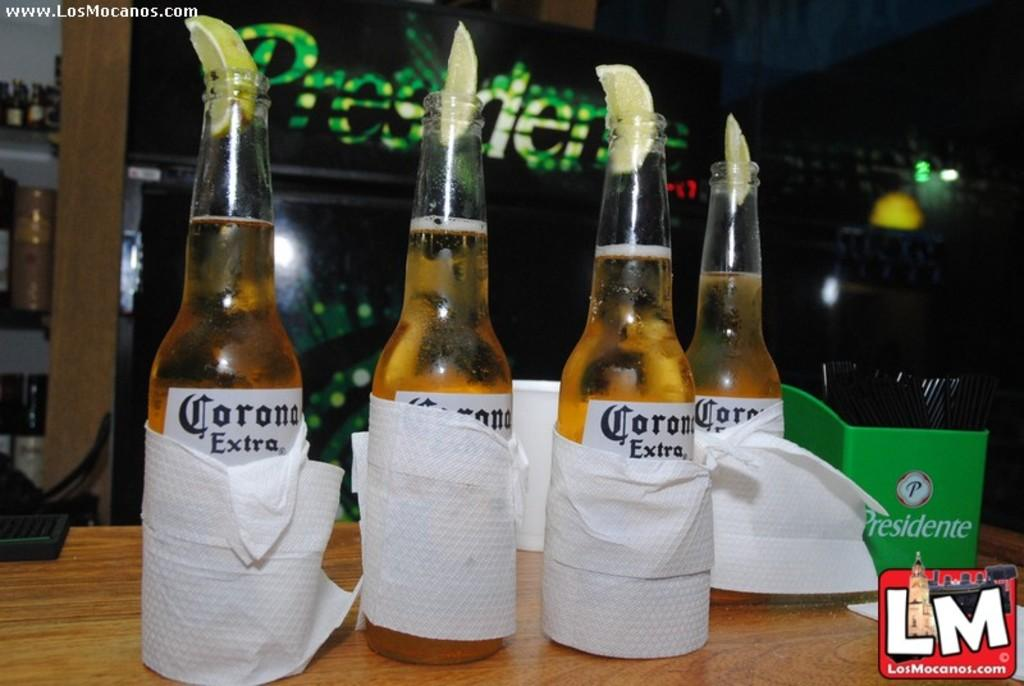<image>
Provide a brief description of the given image. Four bottles of Corona Extra wrapped in napkins. 